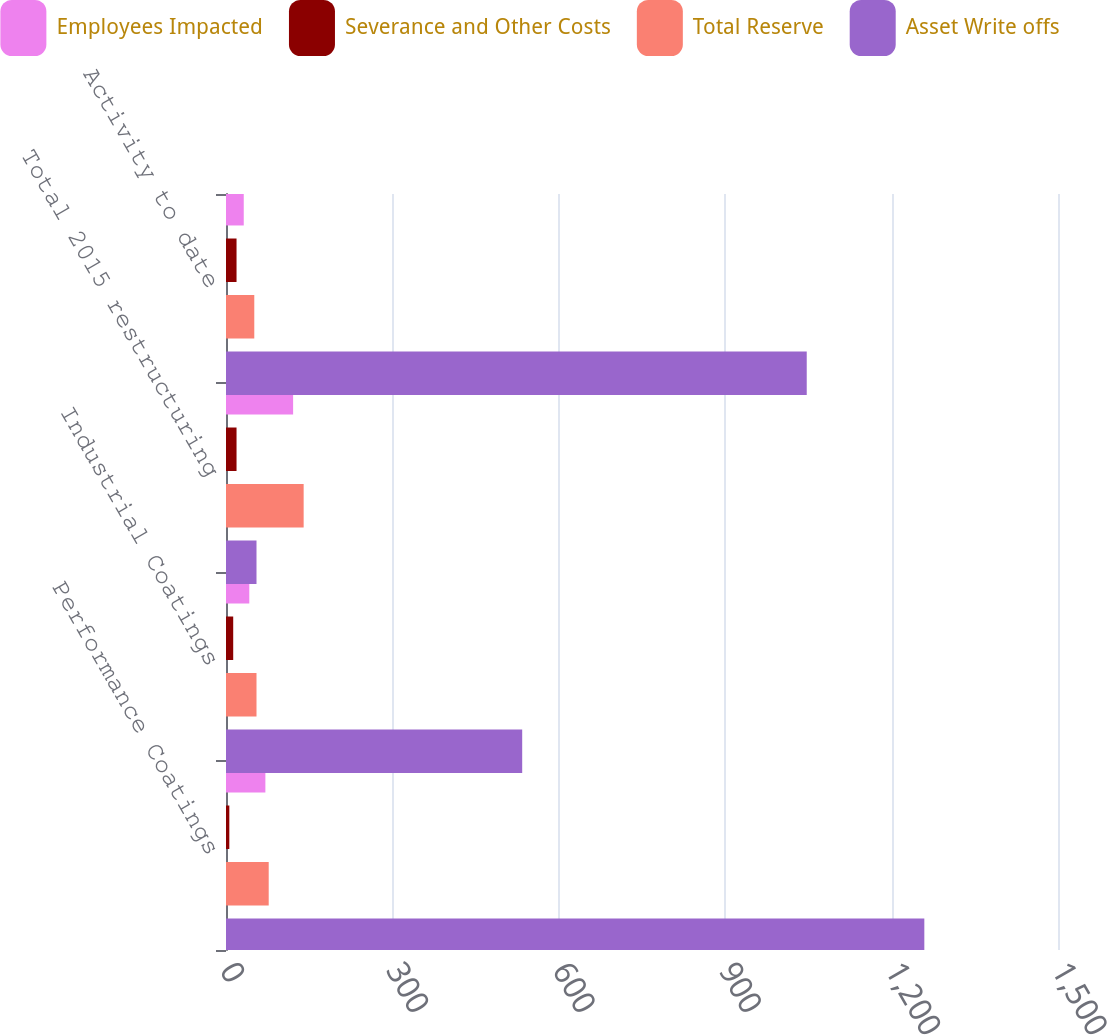Convert chart to OTSL. <chart><loc_0><loc_0><loc_500><loc_500><stacked_bar_chart><ecel><fcel>Performance Coatings<fcel>Industrial Coatings<fcel>Total 2015 restructuring<fcel>Activity to date<nl><fcel>Employees Impacted<fcel>71<fcel>42<fcel>121<fcel>32<nl><fcel>Severance and Other Costs<fcel>6<fcel>13<fcel>19<fcel>19<nl><fcel>Total Reserve<fcel>77<fcel>55<fcel>140<fcel>51<nl><fcel>Asset Write offs<fcel>1259<fcel>534<fcel>55<fcel>1047<nl></chart> 